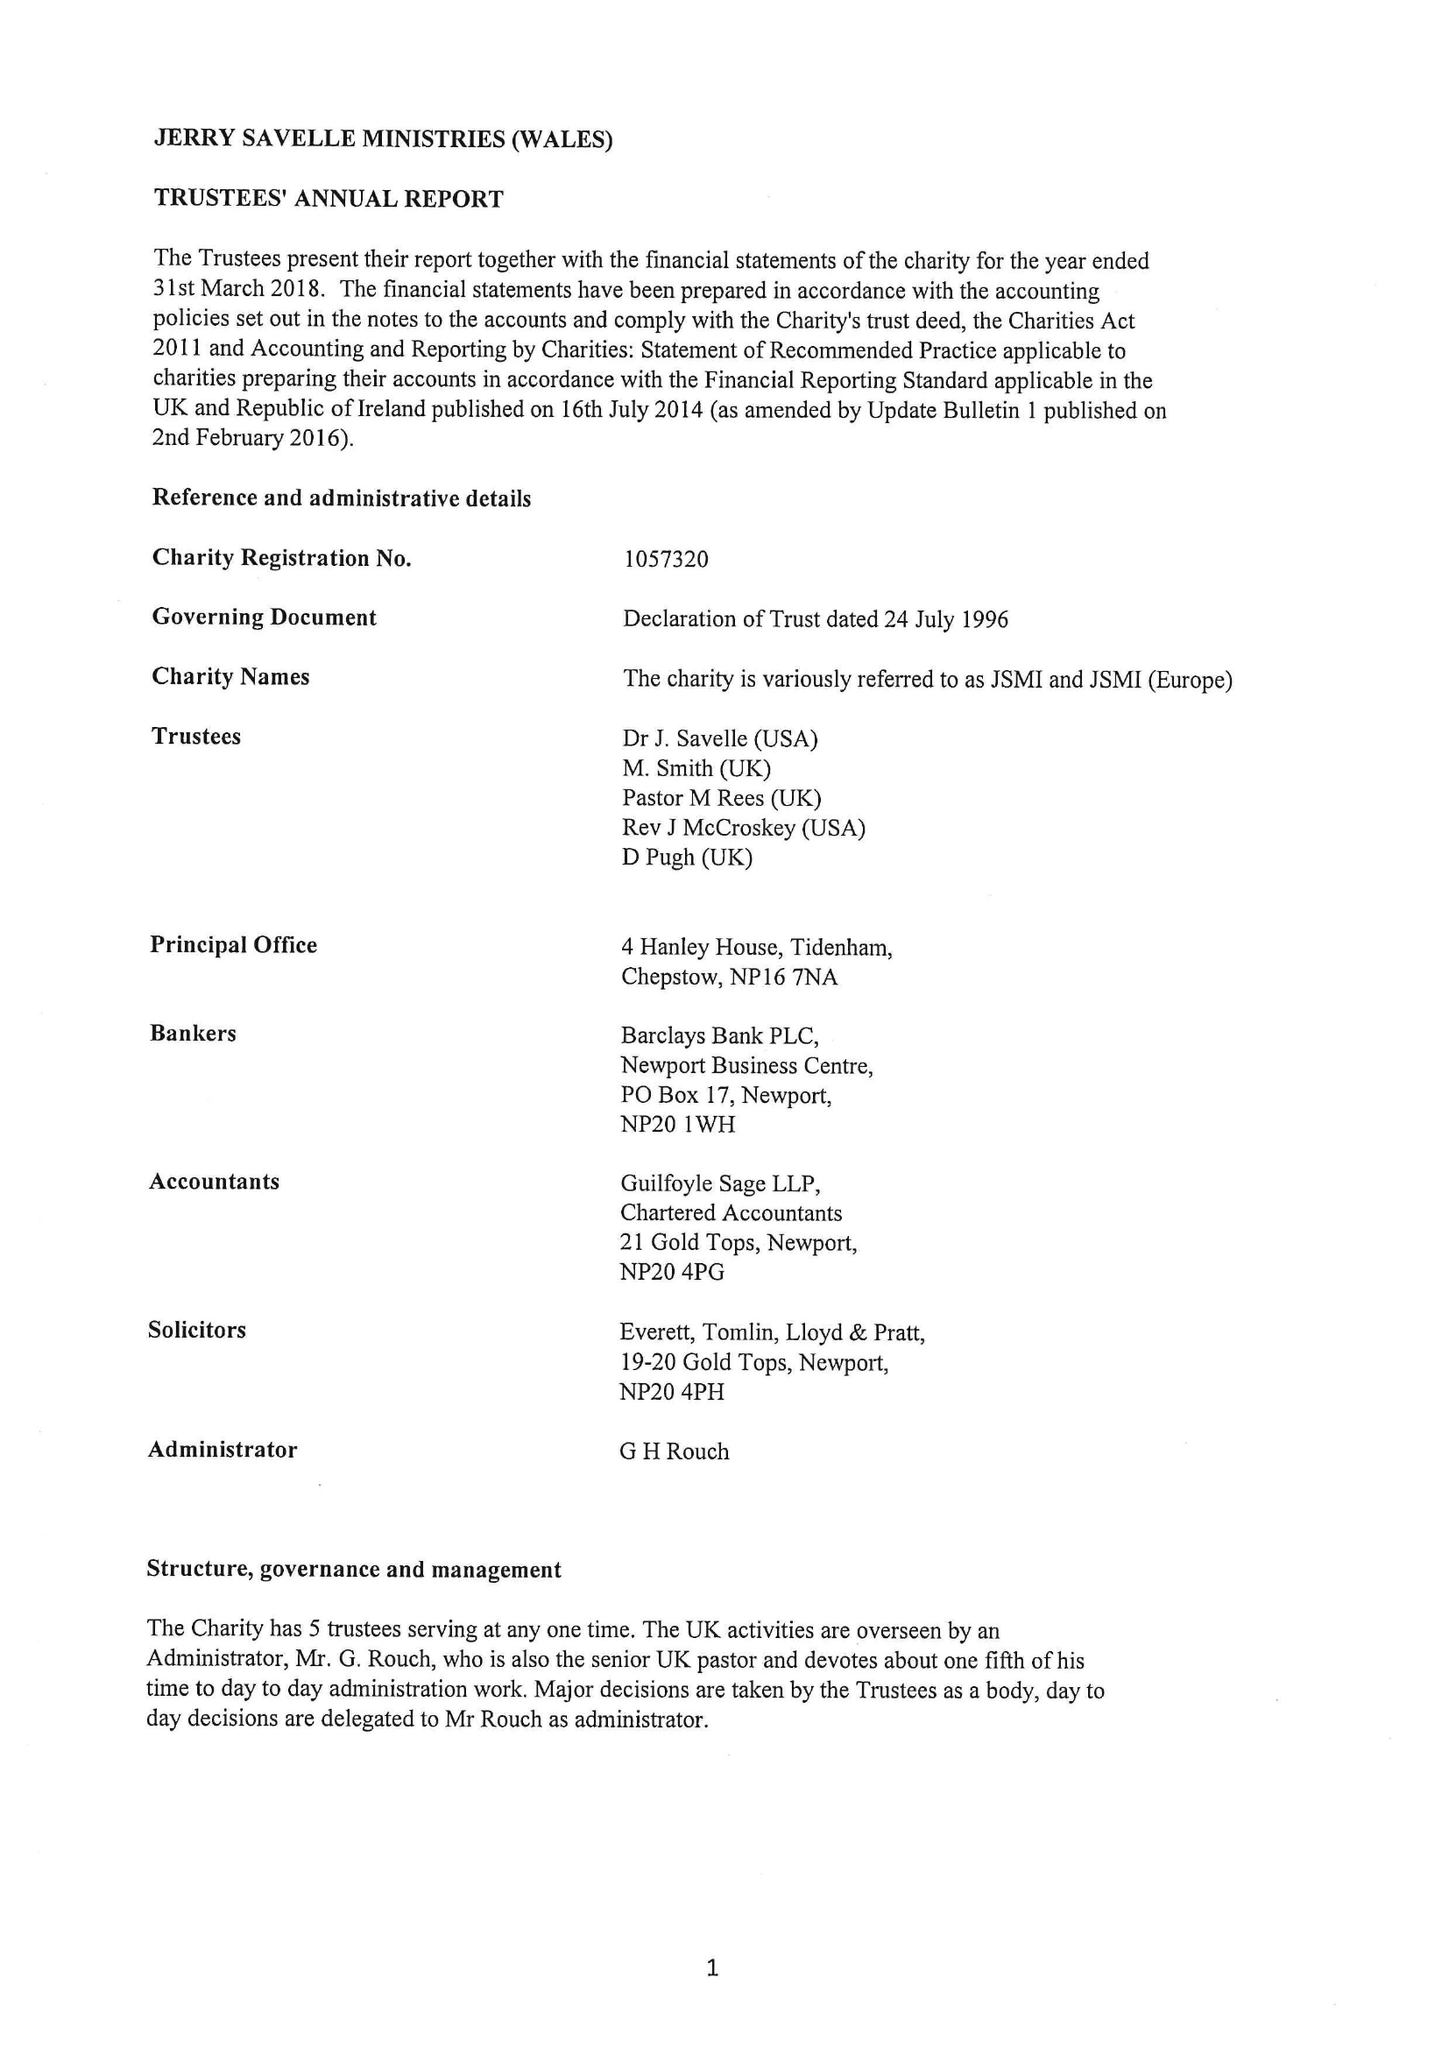What is the value for the address__street_line?
Answer the question using a single word or phrase. None 